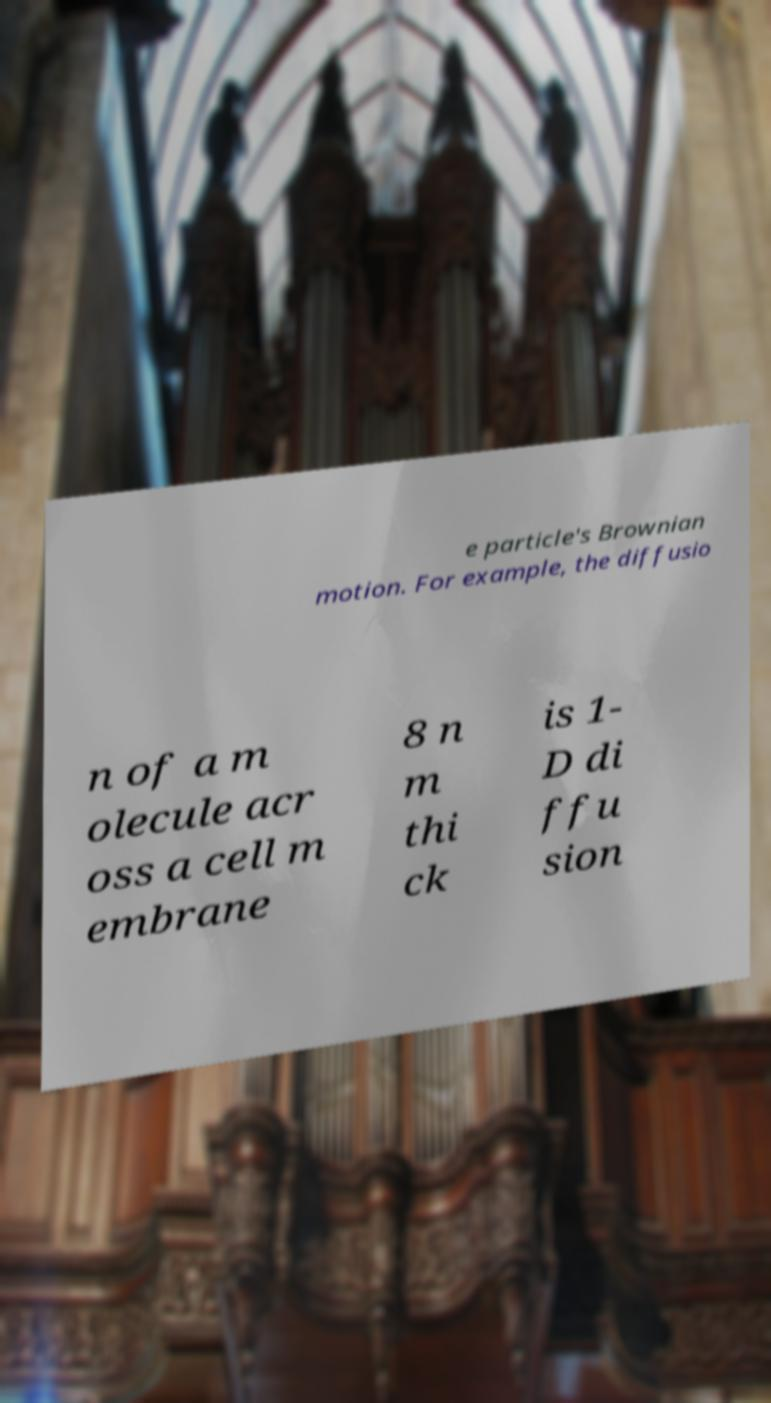Can you accurately transcribe the text from the provided image for me? e particle's Brownian motion. For example, the diffusio n of a m olecule acr oss a cell m embrane 8 n m thi ck is 1- D di ffu sion 